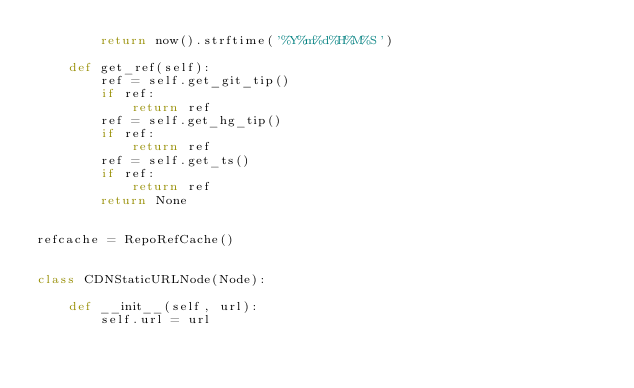Convert code to text. <code><loc_0><loc_0><loc_500><loc_500><_Python_>        return now().strftime('%Y%m%d%H%M%S')

    def get_ref(self):
        ref = self.get_git_tip()
        if ref:
            return ref
        ref = self.get_hg_tip()
        if ref:
            return ref
        ref = self.get_ts()
        if ref:
            return ref
        return None


refcache = RepoRefCache()


class CDNStaticURLNode(Node):

    def __init__(self, url):
        self.url = url
</code> 